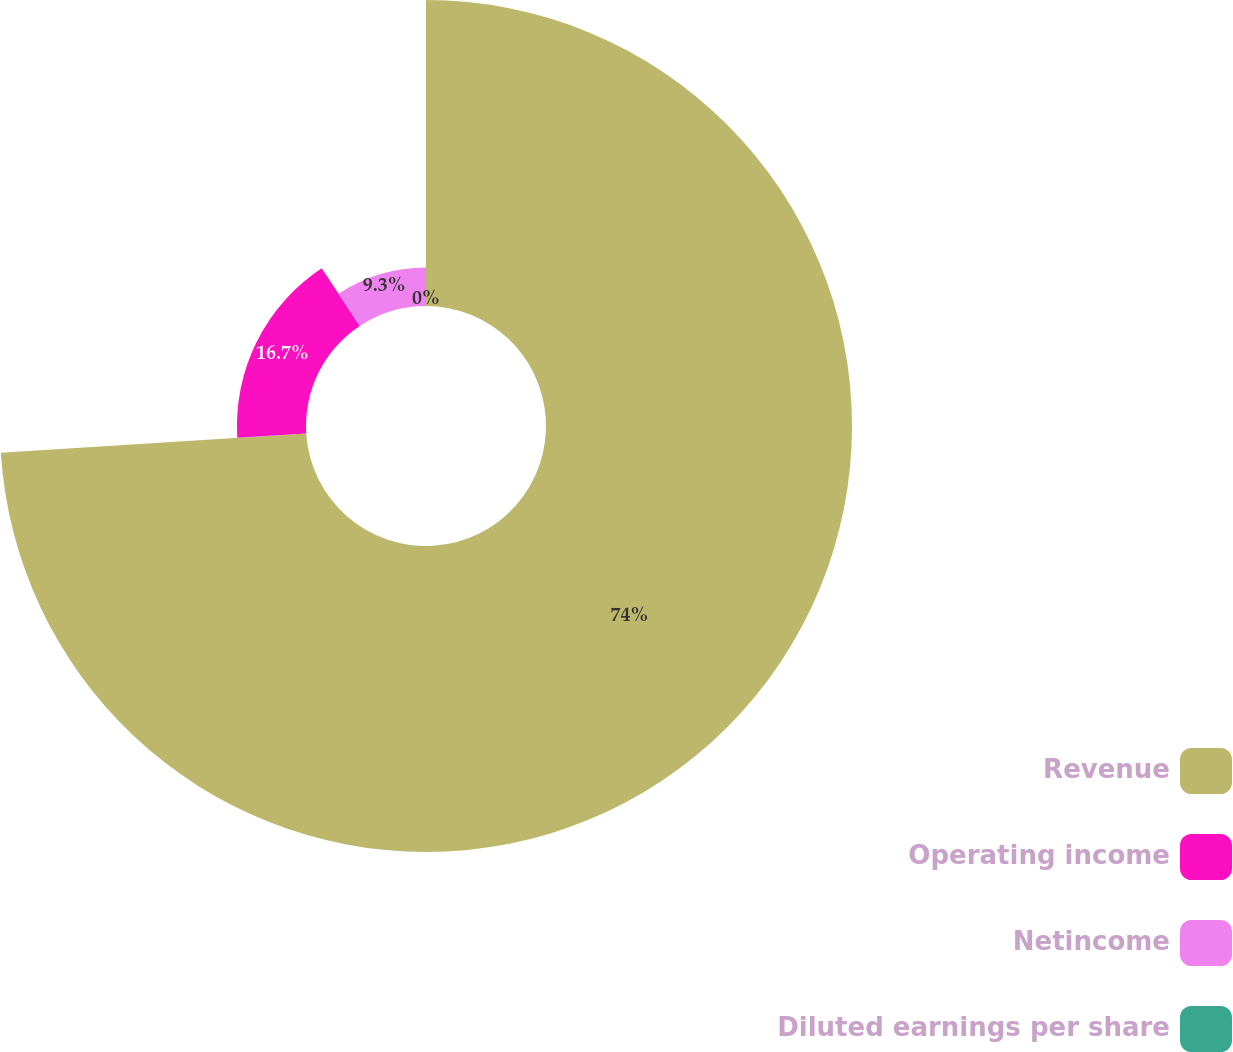Convert chart to OTSL. <chart><loc_0><loc_0><loc_500><loc_500><pie_chart><fcel>Revenue<fcel>Operating income<fcel>Netincome<fcel>Diluted earnings per share<nl><fcel>74.0%<fcel>16.7%<fcel>9.3%<fcel>0.0%<nl></chart> 